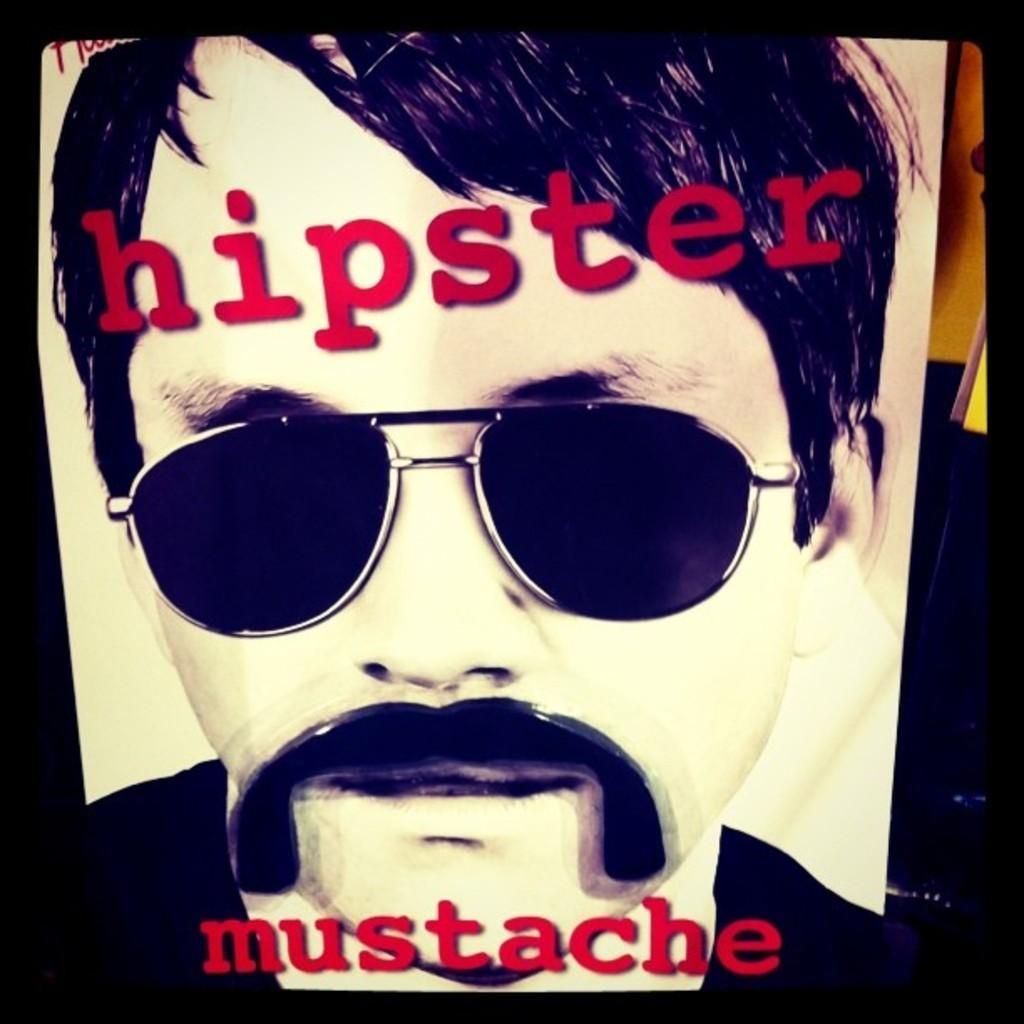Could you give a brief overview of what you see in this image? The picture consists of an edited image. In this picture there is a person with spectacles. At the bottom there is text. At the top there is text. 